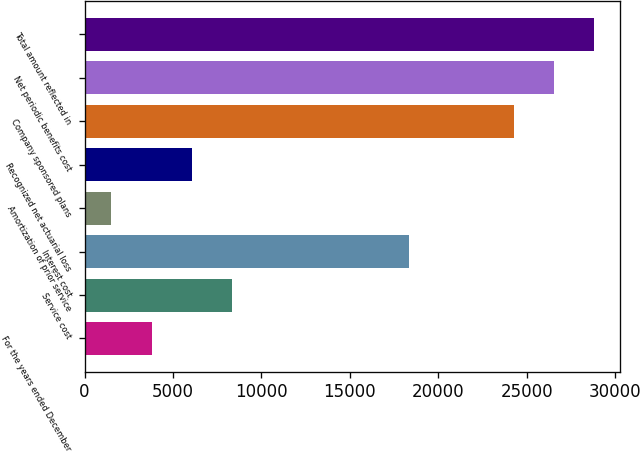Convert chart to OTSL. <chart><loc_0><loc_0><loc_500><loc_500><bar_chart><fcel>For the years ended December<fcel>Service cost<fcel>Interest cost<fcel>Amortization of prior service<fcel>Recognized net actuarial loss<fcel>Company sponsored plans<fcel>Net periodic benefits cost<fcel>Total amount reflected in<nl><fcel>3784.3<fcel>8338.9<fcel>18335<fcel>1507<fcel>6061.6<fcel>24280<fcel>26557.3<fcel>28834.6<nl></chart> 